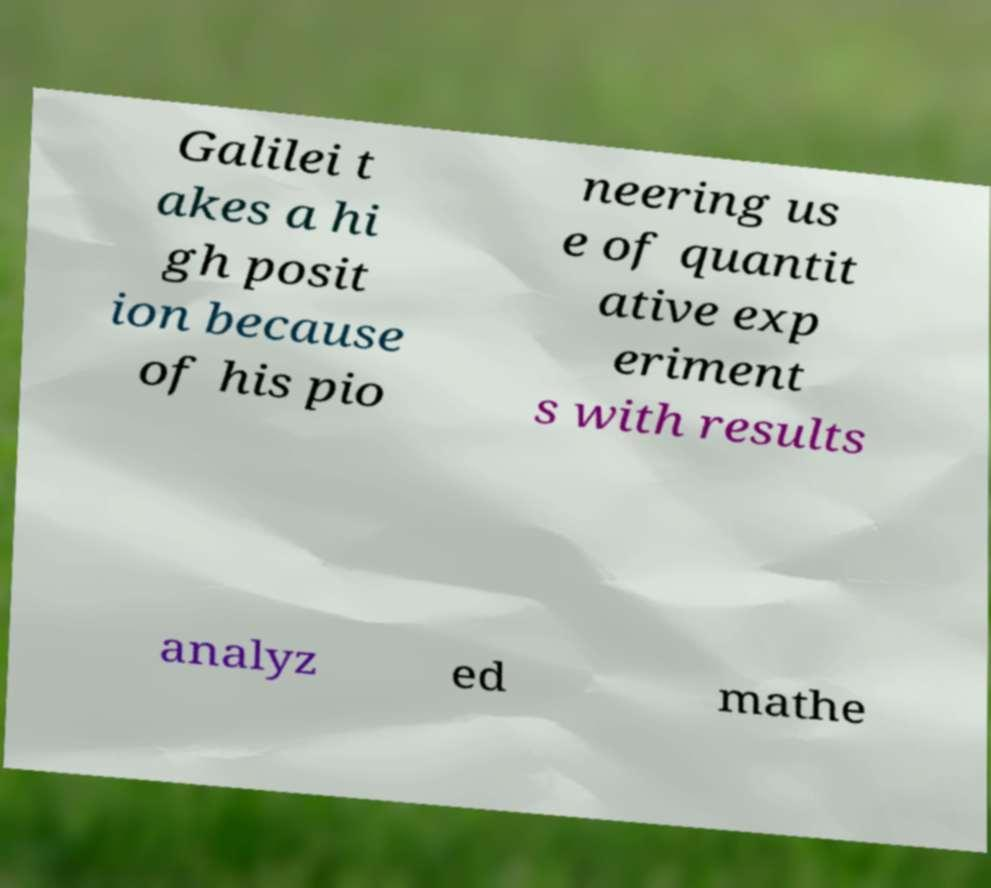Please identify and transcribe the text found in this image. Galilei t akes a hi gh posit ion because of his pio neering us e of quantit ative exp eriment s with results analyz ed mathe 